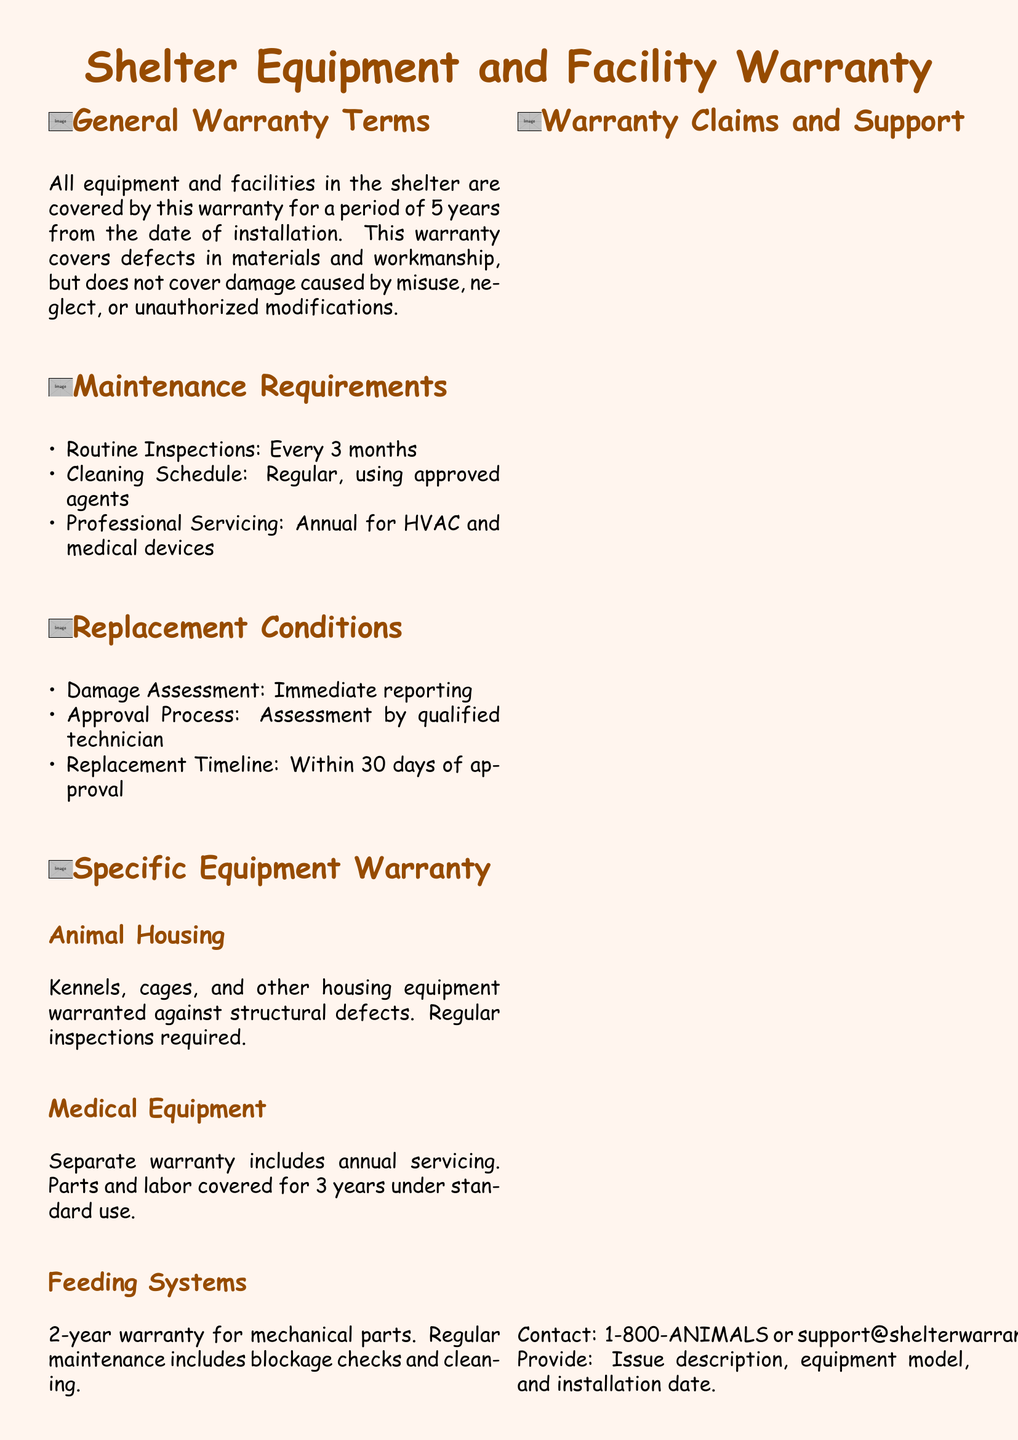what is the warranty period for equipment and facilities? The warranty period is stated to be 5 years from the date of installation.
Answer: 5 years how often are routine inspections required? The document states that routine inspections are required every 3 months.
Answer: Every 3 months what must be included when contacting for warranty claims? The document specifies that the issue description, equipment model, and installation date must be provided.
Answer: Issue description, equipment model, and installation date what is the warranty coverage for medical equipment? The warranty includes parts and labor coverage for 3 years under standard use.
Answer: 3 years what is the replacement timeline after approval? The document outlines that the replacement must occur within 30 days of approval.
Answer: Within 30 days what type of maintenance is required for feeding systems? Regular maintenance includes blockage checks and cleaning as stated in the document.
Answer: Blockage checks and cleaning what is required for animal housing equipment? The document mandates regular inspections for animal housing equipment.
Answer: Regular inspections who should be contacted for warranty claims and support? The document provides a contact number and email, specifically stating to contact 1-800-ANIMALS or support@shelterwarranty.com.
Answer: 1-800-ANIMALS or support@shelterwarranty.com 